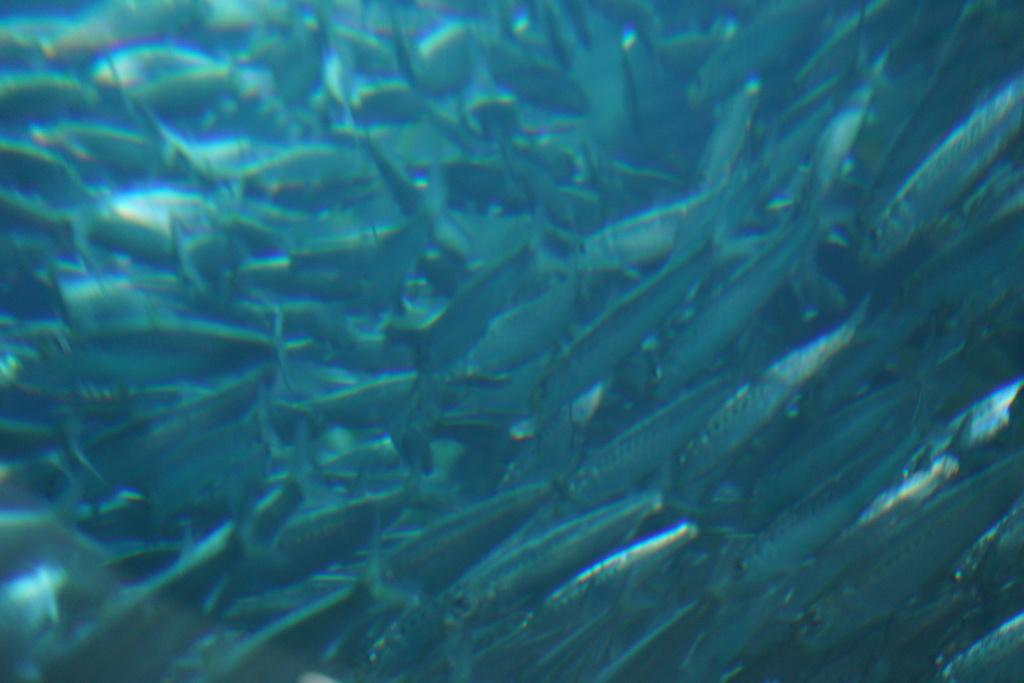What type of animals can be seen in the image? There are fishes in the image. What is the primary element in which the fishes are situated? The fishes are situated in water. What type of yam is being exchanged between the fishes in the image? There is no yam present in the image, and the fishes are not engaging in any exchange. 